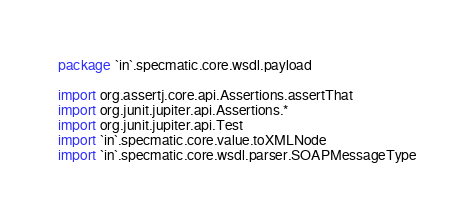Convert code to text. <code><loc_0><loc_0><loc_500><loc_500><_Kotlin_>package `in`.specmatic.core.wsdl.payload

import org.assertj.core.api.Assertions.assertThat
import org.junit.jupiter.api.Assertions.*
import org.junit.jupiter.api.Test
import `in`.specmatic.core.value.toXMLNode
import `in`.specmatic.core.wsdl.parser.SOAPMessageType</code> 